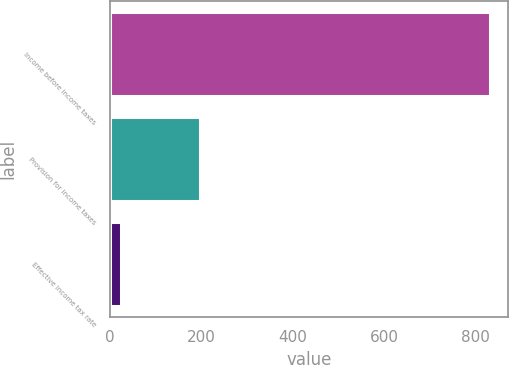Convert chart. <chart><loc_0><loc_0><loc_500><loc_500><bar_chart><fcel>Income before income taxes<fcel>Provision for income taxes<fcel>Effective income tax rate<nl><fcel>830.2<fcel>198<fcel>23.8<nl></chart> 